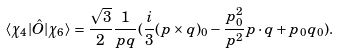Convert formula to latex. <formula><loc_0><loc_0><loc_500><loc_500>\langle \chi _ { 4 } | \hat { O } | \chi _ { 6 } \rangle = \frac { \sqrt { 3 } } { 2 } \frac { 1 } { p q } ( \frac { i } { 3 } ( { p } \times { q } ) _ { 0 } - \frac { p _ { 0 } ^ { 2 } } { p ^ { 2 } } { p } \cdot { q } + p _ { 0 } q _ { 0 } ) .</formula> 